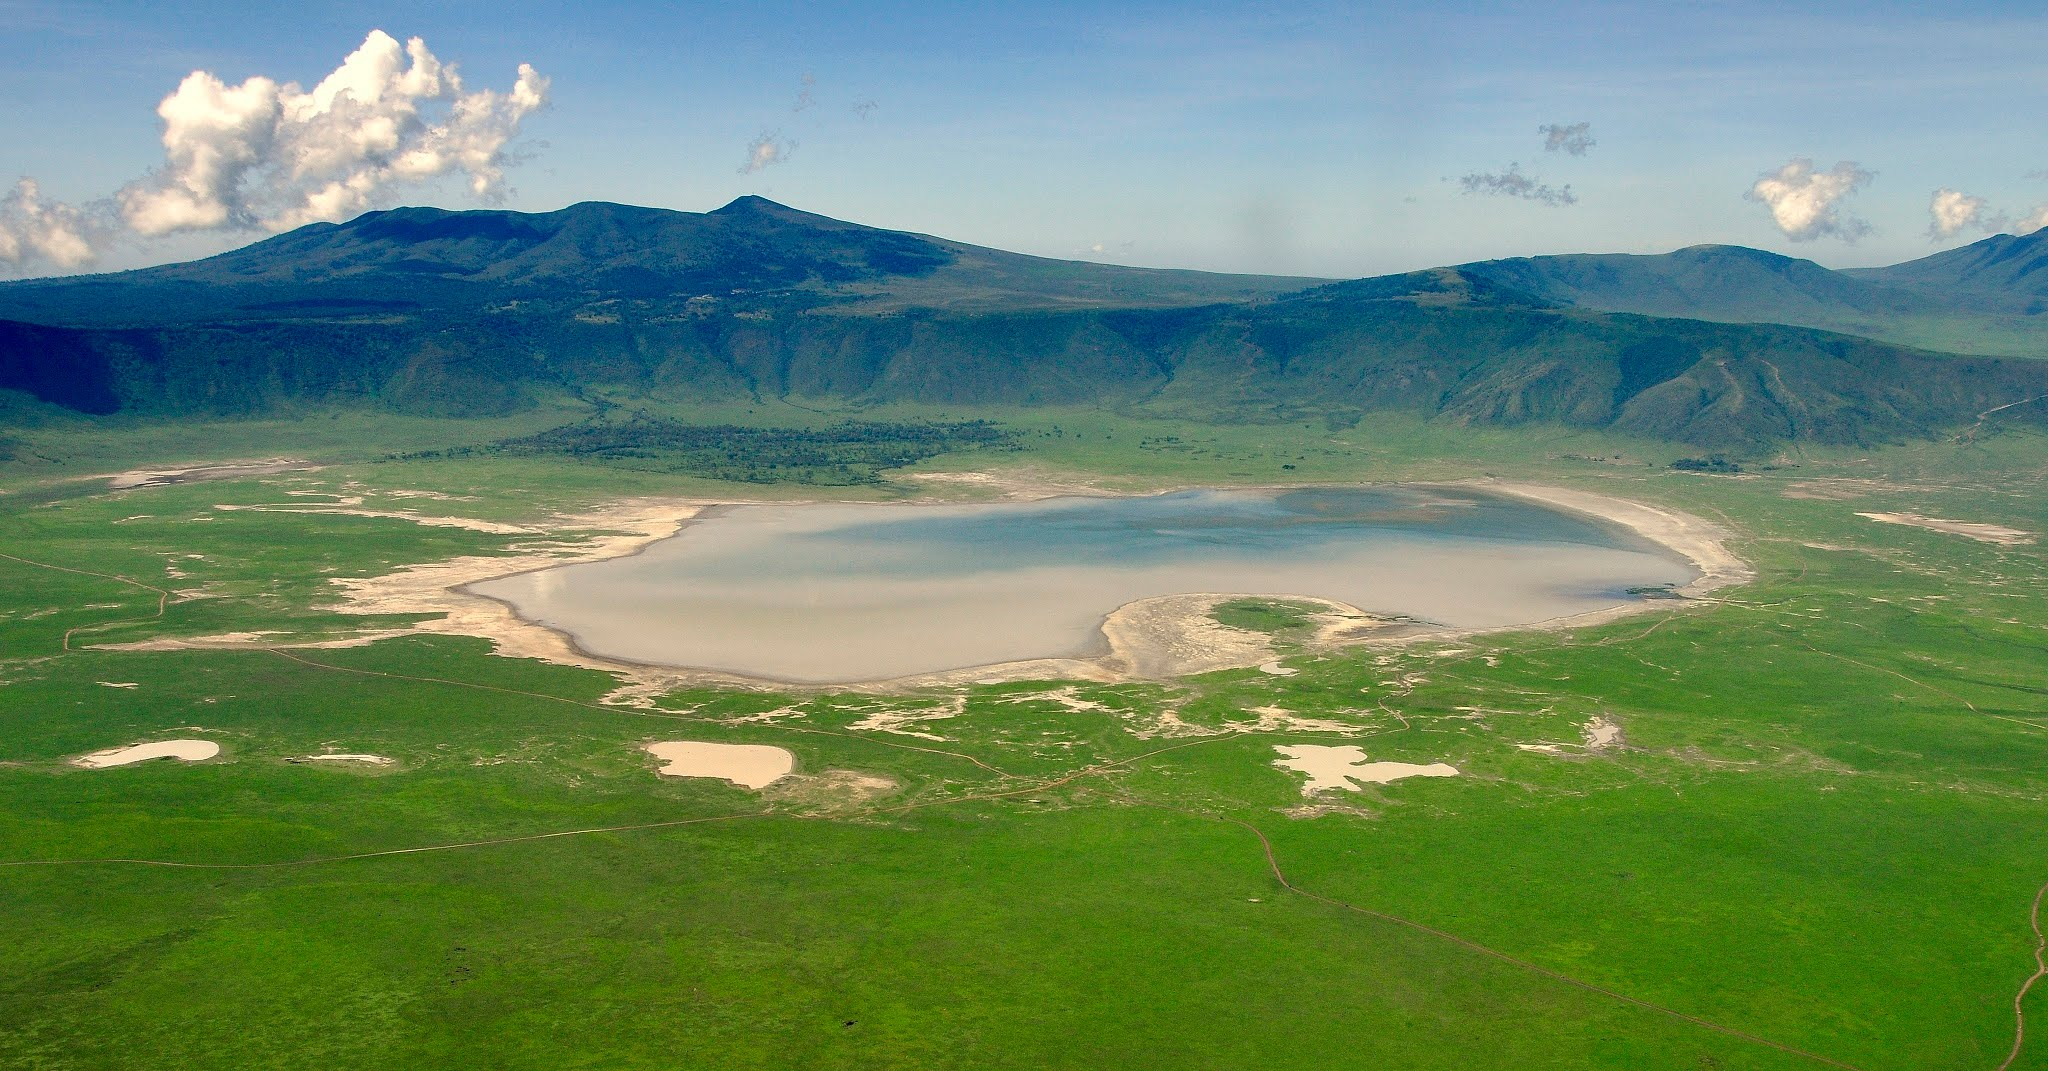Can you tell me about the wildlife that inhabits the Ngorongoro Crater? The Ngorongoro Crater is teeming with wildlife, being one of the most densely packed wildlife areas in the world. It's home to approximately 25,000 animals, including the 'Big Five': lions, elephants, buffalo, leopards, and the critically endangered black rhinoceros. The crater also supports a vast array of other species, such as cheetahs, wildebeest, zebras, and gazelles. The saline waters of the crater's seasonal lake attract flocks of flamingos, while hippos find comfort in the water bodies. As a natural enclosure with rich pasture and permanent water, the Crater provides a haven for these animals year-round, making it an integral part of the Serengeti ecosystem. 